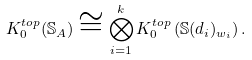<formula> <loc_0><loc_0><loc_500><loc_500>K ^ { t o p } _ { 0 } ( \mathbb { S } _ { A } ) \cong \bigotimes _ { i = 1 } ^ { k } K ^ { t o p } _ { 0 } \left ( \mathbb { S } ( d _ { i } ) _ { w _ { i } } \right ) .</formula> 